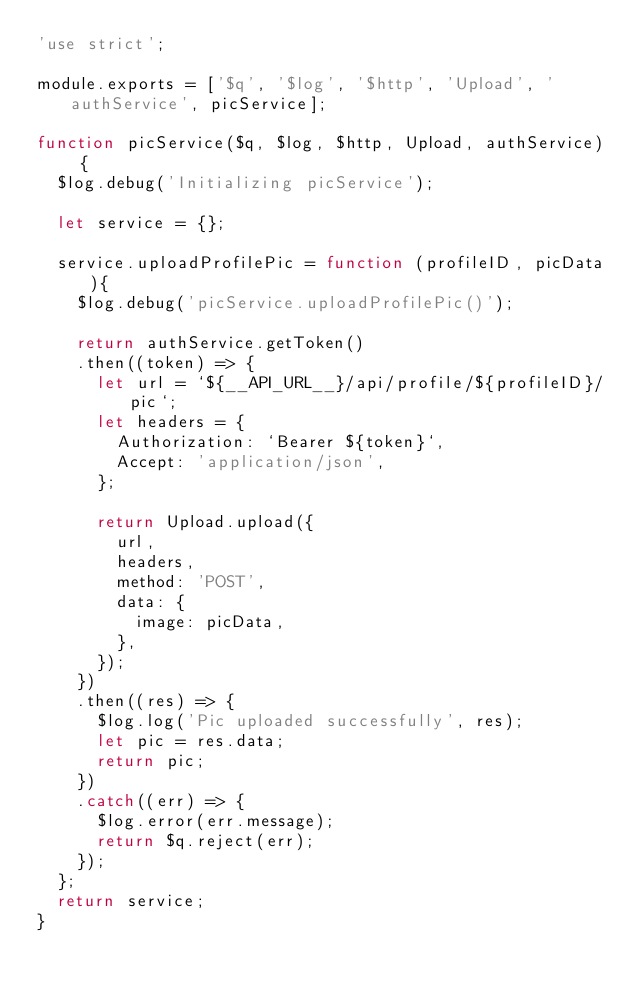Convert code to text. <code><loc_0><loc_0><loc_500><loc_500><_JavaScript_>'use strict';

module.exports = ['$q', '$log', '$http', 'Upload', 'authService', picService];

function picService($q, $log, $http, Upload, authService) {
  $log.debug('Initializing picService');

  let service = {};

  service.uploadProfilePic = function (profileID, picData){
    $log.debug('picService.uploadProfilePic()');

    return authService.getToken()
    .then((token) => {
      let url = `${__API_URL__}/api/profile/${profileID}/pic`;
      let headers = {
        Authorization: `Bearer ${token}`,
        Accept: 'application/json',
      };

      return Upload.upload({
        url,
        headers,
        method: 'POST',
        data: {
          image: picData,
        },
      });
    })
    .then((res) => {
      $log.log('Pic uploaded successfully', res);
      let pic = res.data;
      return pic;
    })
    .catch((err) => {
      $log.error(err.message);
      return $q.reject(err);
    });
  };
  return service;
}
</code> 